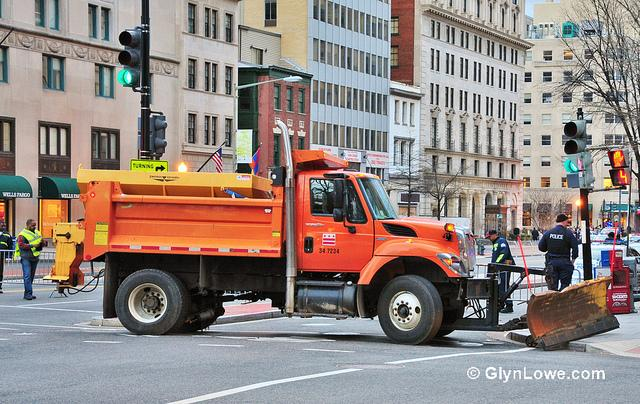Why is the man wearing a yellow vest? Please explain your reasoning. visibility. The visible vest is a neon yellow. neon yellow vests of this type are often worn by professionals who want to be seen for their safety. 